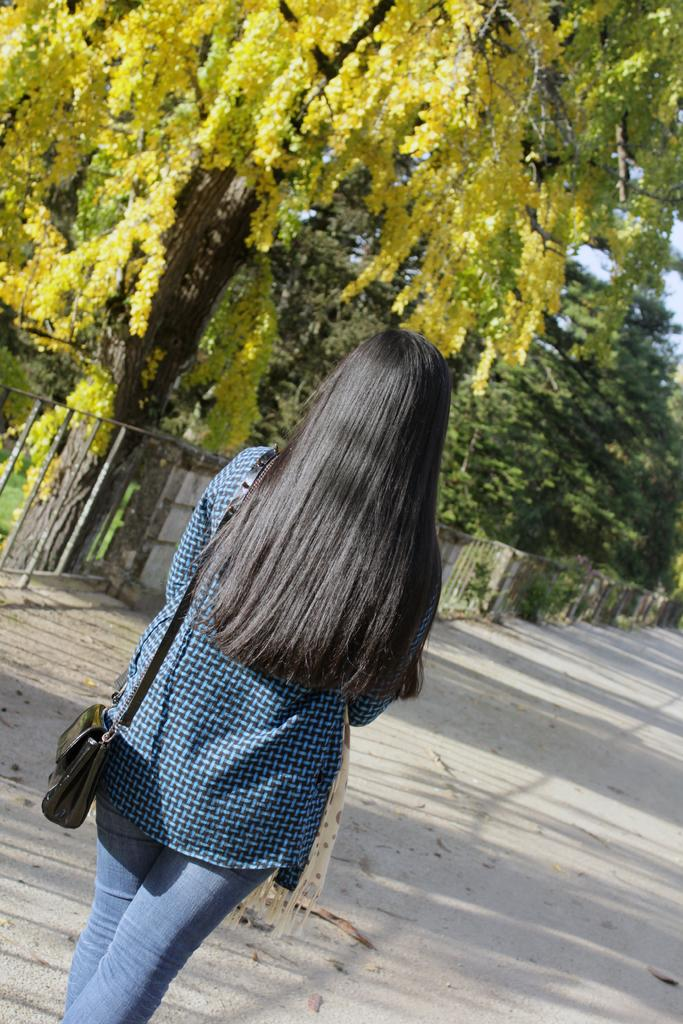Who is present in the image? There is a woman in the image. What type of clothing is the woman wearing? The woman is wearing jeans. What is the woman doing in the image? The woman is walking on the road. What can be seen in the background of the image? There are trees, a fence, and the sky visible in the background of the image. What type of bait is the woman using to catch fish in the image? There is no indication in the image that the woman is fishing or using bait; she is walking on the road. What is the limit of the woman's walking distance in the image? There is no information provided about the woman's walking distance or any limits in the image. 